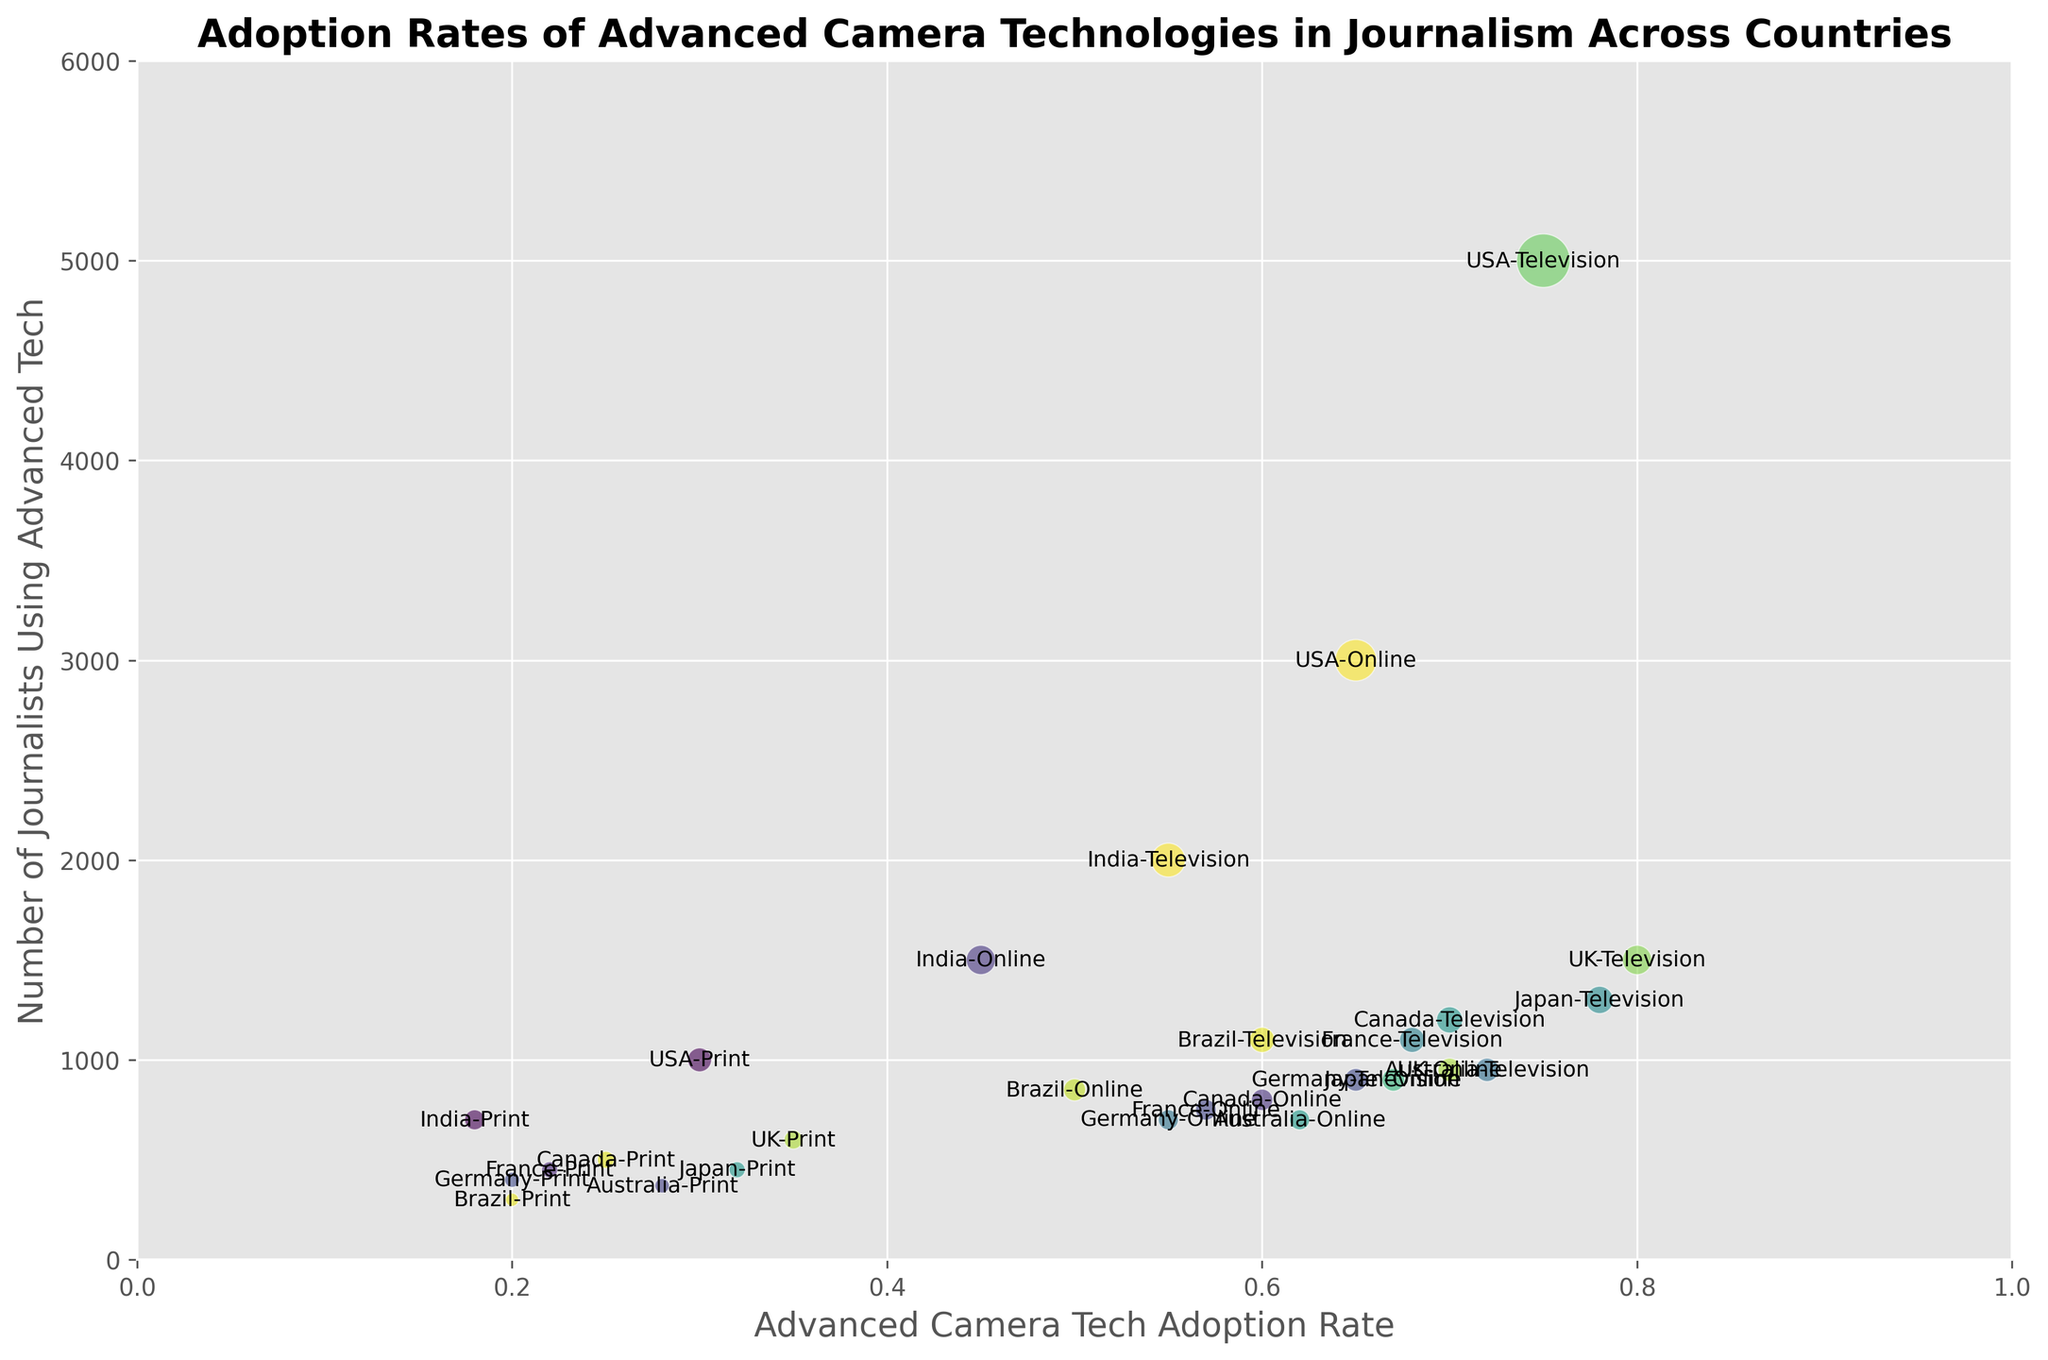What's the country and media type with the highest adoption rate of advanced camera tech? Looking at the x-axis for the highest value, the bubble with the highest adoption rate is at 0.80. The text annotation indicates that it is the UK - Television.
Answer: UK - Television Which country has the lowest number of journalists using advanced camera technologies in online media? Compare the y-axis values for online media in each country. The lowest value for online media is 700 in Australia.
Answer: Australia Which media type in the USA has the smallest bubble? The smallest bubble would correspond to the media with the lowest number of journalists using the technology. For the USA, print media has 1000 journalists, which is the lowest among the three media types (Television, Online, Print).
Answer: Print What is the total number of journalists using advanced camera technologies in the UK across all media types? Sum the number of journalists for Television, Online, and Print in the UK: 1500 (Television) + 950 (Online) + 600 (Print) = 3050.
Answer: 3050 Which country has a higher adoption rate in print media: Germany or Brazil? Compare the x-axis values for print media in Germany and Brazil. Germany's print media adoption rate is 0.20, while Brazil's print media adoption rate is also 0.20. Both countries have the same adoption rate for print media.
Answer: Same Which country and media type have the largest bubble (i.e., the most journalists using the technology)? Look for the largest bubble in the plot. The largest bubble corresponds to 5000 journalists, indicated by the text annotation as USA - Television.
Answer: USA - Television What's the difference in the number of journalists using advanced camera tech in online media between Canada and Japan? Subtract the number of journalists using advanced tech in online media in Canada (800) from Japan (900): 900 - 800 = 100.
Answer: 100 How does the adoption rate of advanced camera tech in Television compare between France and Australia? Look at the x-axis values for Television in France and Australia. France's adoption rate is 0.68 and Australia's is 0.72. Australia's adoption rate is higher.
Answer: Australia Which country shows the most balanced adoption rates across all media types? By examining the widths of the plot, India's adoption rates for Television, Online, and Print show a consistent pattern with values of 0.55, 0.45, and 0.18 compared to other countries with larger discrepancies.
Answer: India 